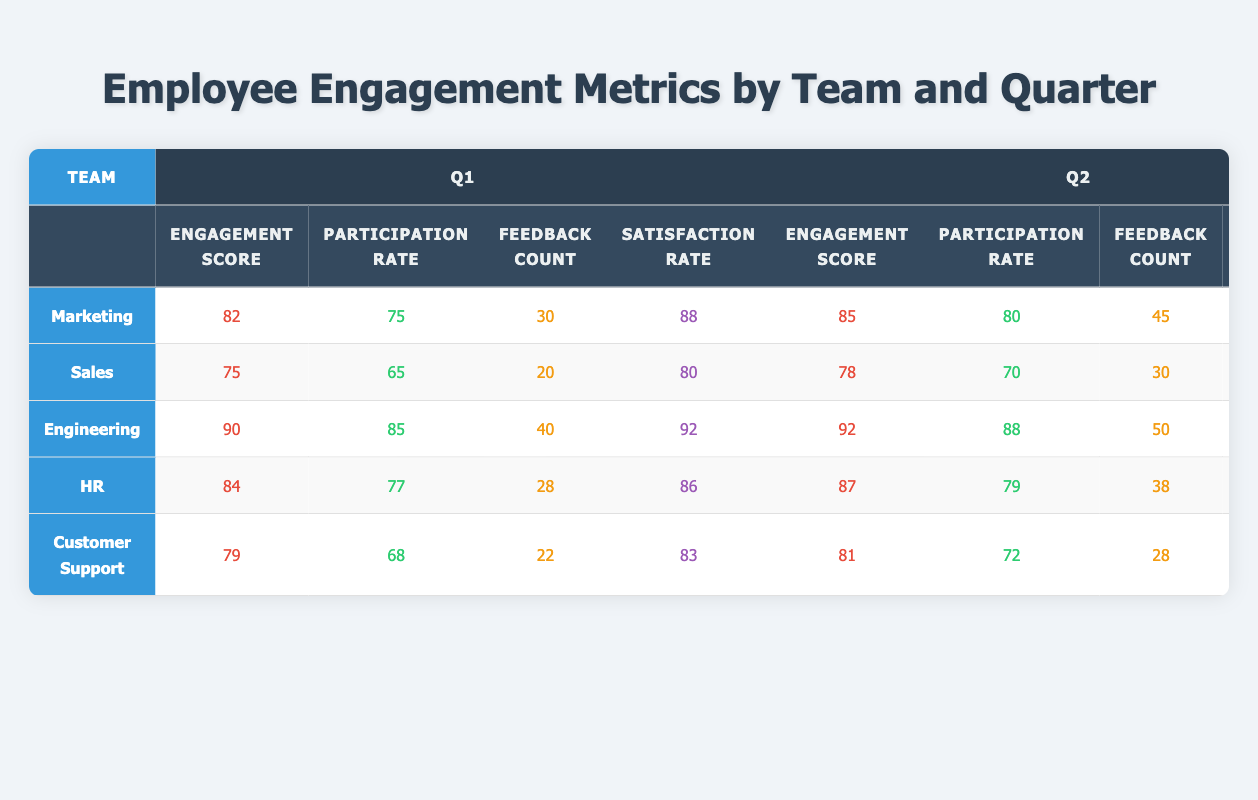What was the Engagement Score for the Sales team in Q2? Referring to the table, find the row for the Sales team and look under the Q2 column for Engagement Score, which is 78.
Answer: 78 What is the highest Satisfaction Rate among all teams in Q3? Check the Satisfaction Rate under Q3 for each team: Marketing (85), Sales (78), Engineering (90), HR (85), Customer Support (80). The highest value is 90 from Engineering.
Answer: 90 Which team had the lowest Participation Rate in Q1? Look at the Participation Rate for each team in Q1: Marketing (75), Sales (65), Engineering (85), HR (77), Customer Support (68). Sales has the lowest value of 65.
Answer: Sales What was the average Engagement Score for the Engineering team across all quarters? Add the Engagement Scores for Engineering: (90 + 92 + 88 + 90) = 360. Divide by 4 quarters: 360/4 = 90.
Answer: 90 Did Marketing's Engagement Score decline from Q1 to Q3? Compare the Engagement Score in Q1 (82) and Q3 (78) for Marketing. Since 78 is less than 82, it did decline.
Answer: Yes What is the difference in Participation Rate between HR and Customer Support in Q4? For HR in Q4, the Participation Rate is 78, and for Customer Support, it is 66. The difference is 78 - 66 = 12.
Answer: 12 Which team had the most Feedback Count in Q2? Review the Feedback Count for each team in Q2: Marketing (45), Sales (30), Engineering (50), HR (38), Customer Support (28). Engineering has the highest count of 50.
Answer: Engineering What was the total Satisfaction Rate for the HR team across all quarters? Add the Satisfaction Rates for HR: (86 + 89 + 85 + 88) = 348.
Answer: 348 How many teams had an Engagement Score of 80 or more in Q1? Check Q1 Engagement Scores: Marketing (82), Sales (75), Engineering (90), HR (84), Customer Support (79). The teams with 80 or more are Marketing, Engineering, and HR – totaling 3 teams.
Answer: 3 What is the Participation Rate trend for the Customer Support team from Q1 to Q4? Observe the Participation Rates for Customer Support: Q1 (68), Q2 (72), Q3 (63), Q4 (66). The trend shows it increased from Q1 to Q2, decreased in Q3, then slightly increased in Q4.
Answer: Increased, decreased, increased 